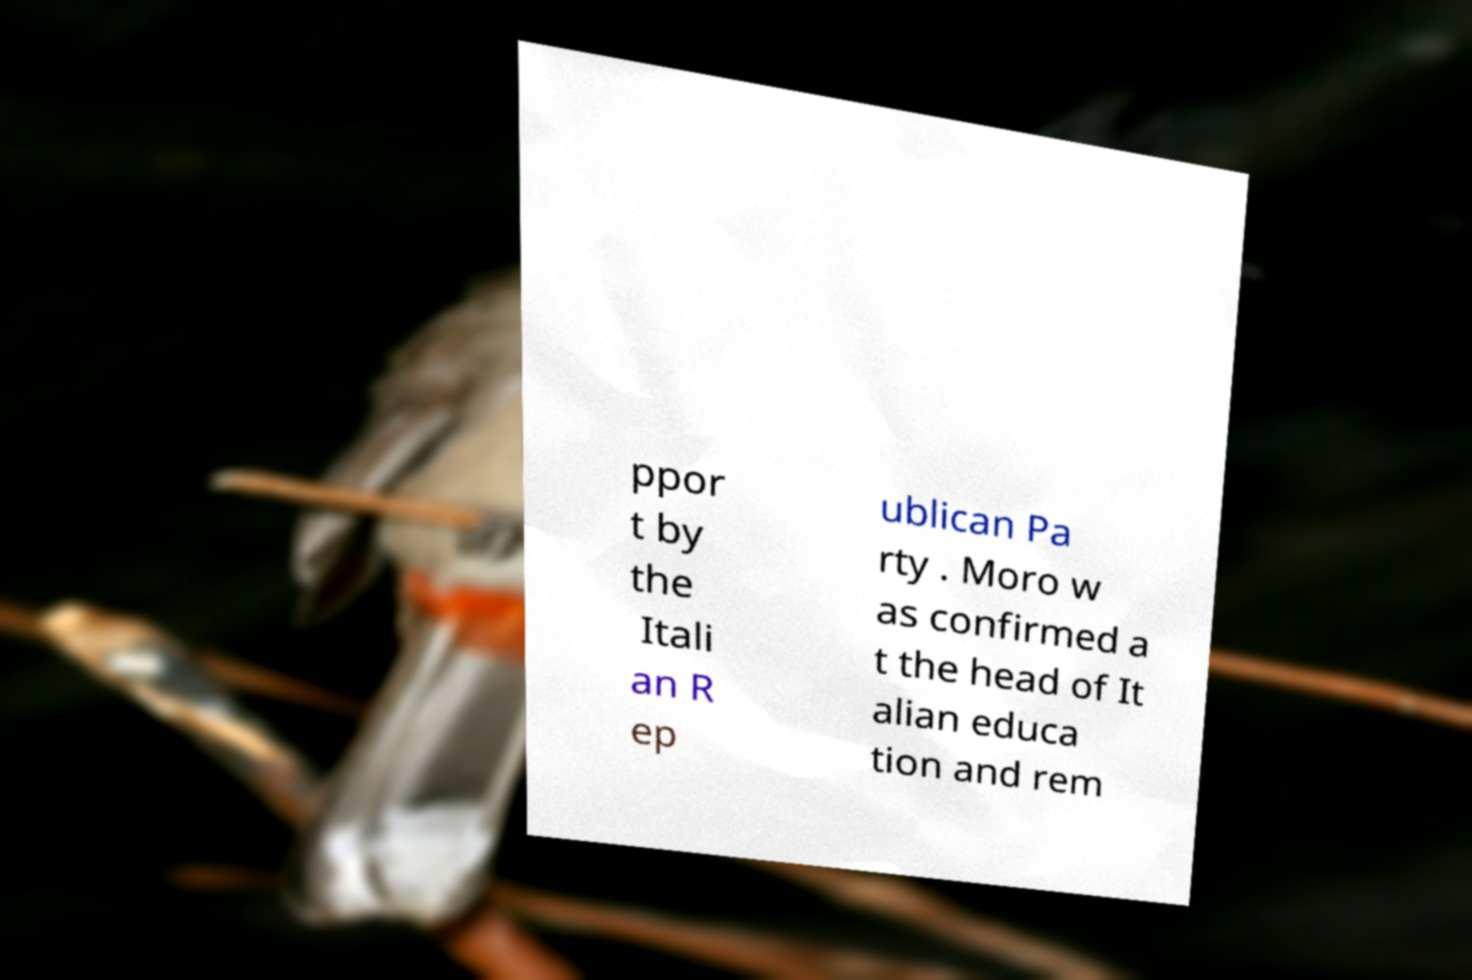There's text embedded in this image that I need extracted. Can you transcribe it verbatim? ppor t by the Itali an R ep ublican Pa rty . Moro w as confirmed a t the head of It alian educa tion and rem 